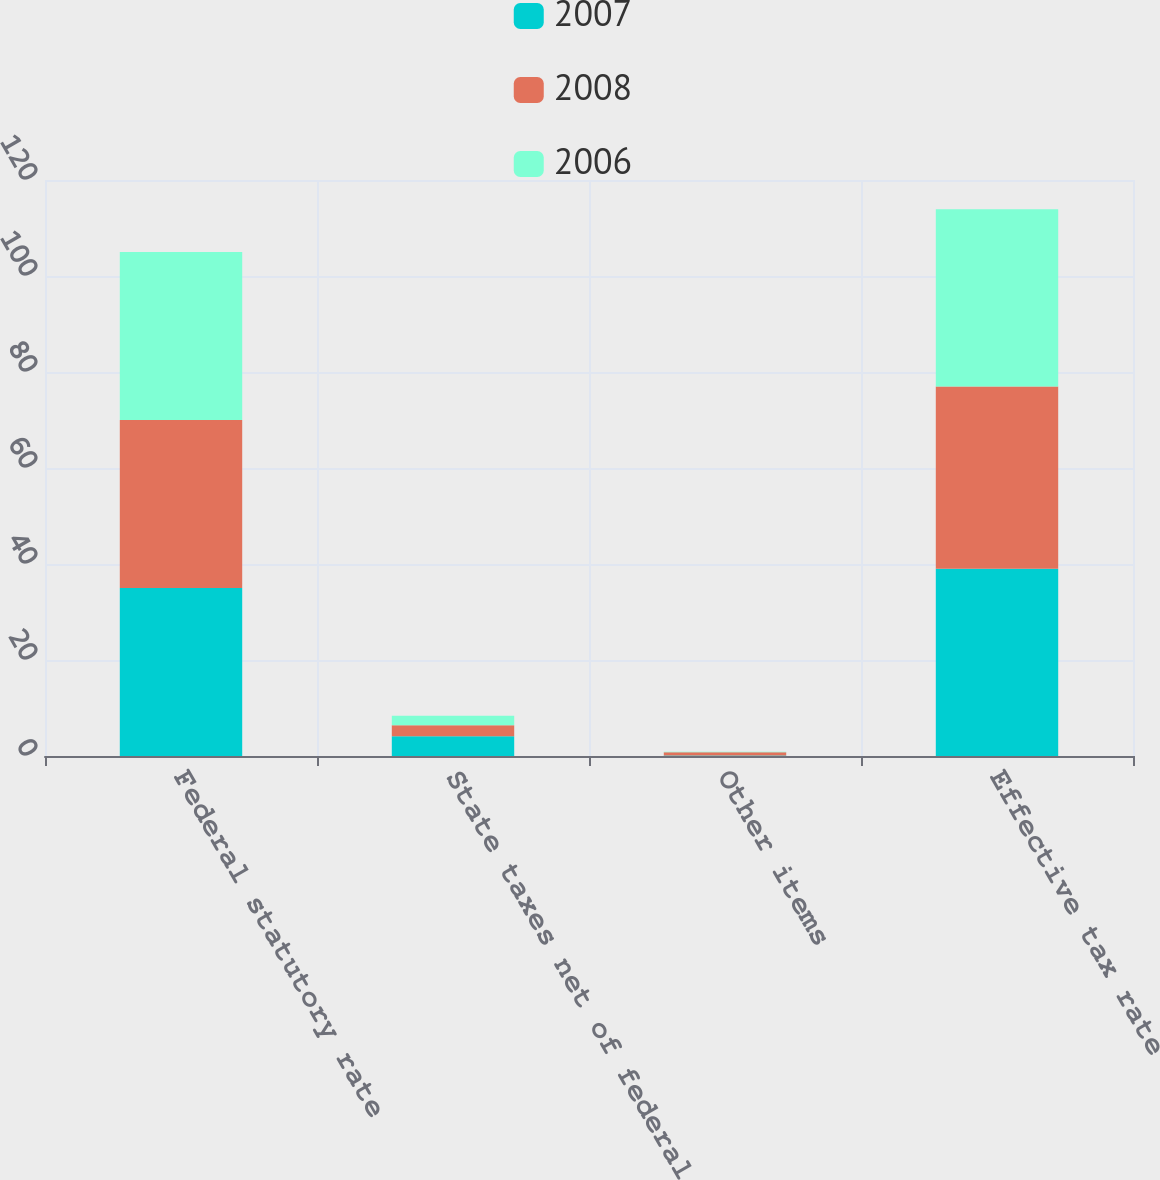<chart> <loc_0><loc_0><loc_500><loc_500><stacked_bar_chart><ecel><fcel>Federal statutory rate<fcel>State taxes net of federal<fcel>Other items<fcel>Effective tax rate<nl><fcel>2007<fcel>35<fcel>4.1<fcel>0.1<fcel>39<nl><fcel>2008<fcel>35<fcel>2.3<fcel>0.7<fcel>38<nl><fcel>2006<fcel>35<fcel>2<fcel>0.1<fcel>36.9<nl></chart> 